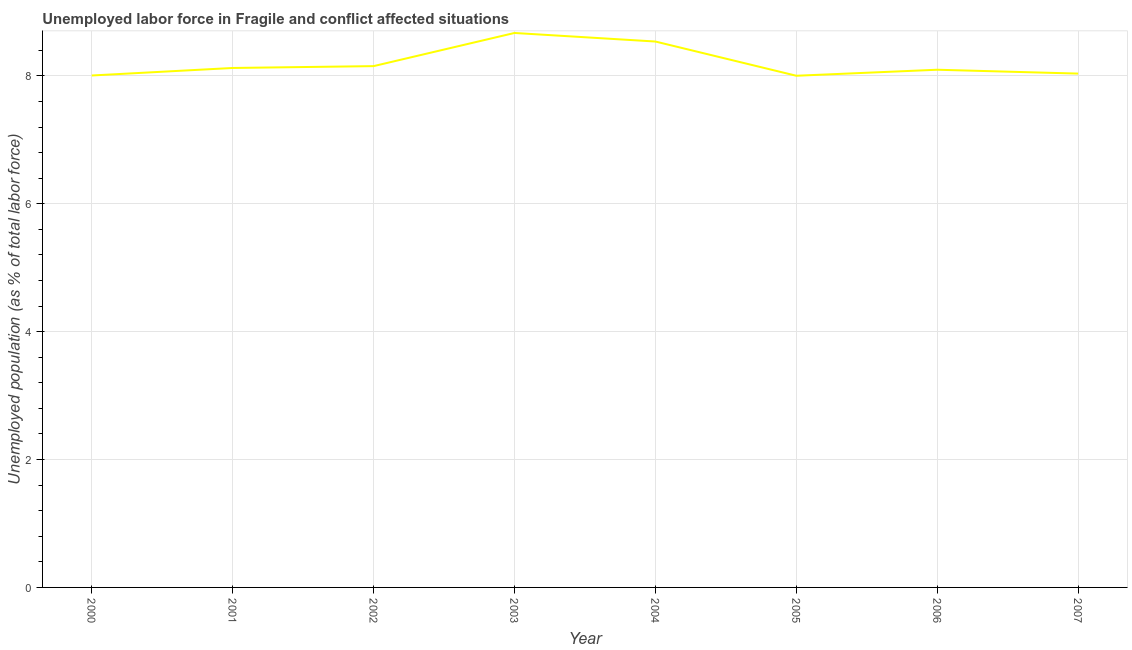What is the total unemployed population in 2005?
Offer a very short reply. 8. Across all years, what is the maximum total unemployed population?
Provide a short and direct response. 8.67. Across all years, what is the minimum total unemployed population?
Your answer should be very brief. 8. In which year was the total unemployed population maximum?
Offer a very short reply. 2003. In which year was the total unemployed population minimum?
Make the answer very short. 2005. What is the sum of the total unemployed population?
Your answer should be very brief. 65.63. What is the difference between the total unemployed population in 2003 and 2006?
Your answer should be compact. 0.58. What is the average total unemployed population per year?
Keep it short and to the point. 8.2. What is the median total unemployed population?
Your answer should be compact. 8.11. In how many years, is the total unemployed population greater than 5.2 %?
Ensure brevity in your answer.  8. What is the ratio of the total unemployed population in 2004 to that in 2007?
Provide a short and direct response. 1.06. Is the total unemployed population in 2000 less than that in 2007?
Your answer should be compact. Yes. What is the difference between the highest and the second highest total unemployed population?
Ensure brevity in your answer.  0.13. What is the difference between the highest and the lowest total unemployed population?
Your answer should be compact. 0.67. In how many years, is the total unemployed population greater than the average total unemployed population taken over all years?
Your response must be concise. 2. How many lines are there?
Ensure brevity in your answer.  1. Does the graph contain any zero values?
Offer a terse response. No. What is the title of the graph?
Your answer should be very brief. Unemployed labor force in Fragile and conflict affected situations. What is the label or title of the Y-axis?
Your response must be concise. Unemployed population (as % of total labor force). What is the Unemployed population (as % of total labor force) in 2000?
Provide a succinct answer. 8.01. What is the Unemployed population (as % of total labor force) in 2001?
Give a very brief answer. 8.12. What is the Unemployed population (as % of total labor force) in 2002?
Your answer should be compact. 8.15. What is the Unemployed population (as % of total labor force) of 2003?
Ensure brevity in your answer.  8.67. What is the Unemployed population (as % of total labor force) of 2004?
Your answer should be very brief. 8.54. What is the Unemployed population (as % of total labor force) in 2005?
Offer a very short reply. 8. What is the Unemployed population (as % of total labor force) in 2006?
Offer a very short reply. 8.1. What is the Unemployed population (as % of total labor force) in 2007?
Offer a very short reply. 8.04. What is the difference between the Unemployed population (as % of total labor force) in 2000 and 2001?
Make the answer very short. -0.12. What is the difference between the Unemployed population (as % of total labor force) in 2000 and 2002?
Provide a succinct answer. -0.15. What is the difference between the Unemployed population (as % of total labor force) in 2000 and 2003?
Keep it short and to the point. -0.67. What is the difference between the Unemployed population (as % of total labor force) in 2000 and 2004?
Keep it short and to the point. -0.53. What is the difference between the Unemployed population (as % of total labor force) in 2000 and 2005?
Ensure brevity in your answer.  0. What is the difference between the Unemployed population (as % of total labor force) in 2000 and 2006?
Your response must be concise. -0.09. What is the difference between the Unemployed population (as % of total labor force) in 2000 and 2007?
Your answer should be compact. -0.03. What is the difference between the Unemployed population (as % of total labor force) in 2001 and 2002?
Offer a terse response. -0.03. What is the difference between the Unemployed population (as % of total labor force) in 2001 and 2003?
Ensure brevity in your answer.  -0.55. What is the difference between the Unemployed population (as % of total labor force) in 2001 and 2004?
Your answer should be compact. -0.41. What is the difference between the Unemployed population (as % of total labor force) in 2001 and 2005?
Your response must be concise. 0.12. What is the difference between the Unemployed population (as % of total labor force) in 2001 and 2006?
Your answer should be very brief. 0.03. What is the difference between the Unemployed population (as % of total labor force) in 2001 and 2007?
Your answer should be compact. 0.09. What is the difference between the Unemployed population (as % of total labor force) in 2002 and 2003?
Make the answer very short. -0.52. What is the difference between the Unemployed population (as % of total labor force) in 2002 and 2004?
Offer a terse response. -0.38. What is the difference between the Unemployed population (as % of total labor force) in 2002 and 2005?
Ensure brevity in your answer.  0.15. What is the difference between the Unemployed population (as % of total labor force) in 2002 and 2006?
Provide a short and direct response. 0.06. What is the difference between the Unemployed population (as % of total labor force) in 2002 and 2007?
Your answer should be compact. 0.12. What is the difference between the Unemployed population (as % of total labor force) in 2003 and 2004?
Your answer should be compact. 0.13. What is the difference between the Unemployed population (as % of total labor force) in 2003 and 2005?
Your answer should be compact. 0.67. What is the difference between the Unemployed population (as % of total labor force) in 2003 and 2006?
Offer a very short reply. 0.58. What is the difference between the Unemployed population (as % of total labor force) in 2003 and 2007?
Ensure brevity in your answer.  0.64. What is the difference between the Unemployed population (as % of total labor force) in 2004 and 2005?
Offer a terse response. 0.54. What is the difference between the Unemployed population (as % of total labor force) in 2004 and 2006?
Make the answer very short. 0.44. What is the difference between the Unemployed population (as % of total labor force) in 2004 and 2007?
Offer a terse response. 0.5. What is the difference between the Unemployed population (as % of total labor force) in 2005 and 2006?
Offer a terse response. -0.09. What is the difference between the Unemployed population (as % of total labor force) in 2005 and 2007?
Offer a terse response. -0.03. What is the difference between the Unemployed population (as % of total labor force) in 2006 and 2007?
Give a very brief answer. 0.06. What is the ratio of the Unemployed population (as % of total labor force) in 2000 to that in 2002?
Keep it short and to the point. 0.98. What is the ratio of the Unemployed population (as % of total labor force) in 2000 to that in 2003?
Offer a terse response. 0.92. What is the ratio of the Unemployed population (as % of total labor force) in 2000 to that in 2004?
Provide a short and direct response. 0.94. What is the ratio of the Unemployed population (as % of total labor force) in 2000 to that in 2005?
Offer a very short reply. 1. What is the ratio of the Unemployed population (as % of total labor force) in 2000 to that in 2006?
Offer a very short reply. 0.99. What is the ratio of the Unemployed population (as % of total labor force) in 2000 to that in 2007?
Ensure brevity in your answer.  1. What is the ratio of the Unemployed population (as % of total labor force) in 2001 to that in 2002?
Offer a terse response. 1. What is the ratio of the Unemployed population (as % of total labor force) in 2001 to that in 2003?
Provide a short and direct response. 0.94. What is the ratio of the Unemployed population (as % of total labor force) in 2001 to that in 2005?
Ensure brevity in your answer.  1.01. What is the ratio of the Unemployed population (as % of total labor force) in 2001 to that in 2006?
Give a very brief answer. 1. What is the ratio of the Unemployed population (as % of total labor force) in 2002 to that in 2003?
Offer a terse response. 0.94. What is the ratio of the Unemployed population (as % of total labor force) in 2002 to that in 2004?
Make the answer very short. 0.95. What is the ratio of the Unemployed population (as % of total labor force) in 2002 to that in 2005?
Provide a succinct answer. 1.02. What is the ratio of the Unemployed population (as % of total labor force) in 2003 to that in 2004?
Offer a very short reply. 1.02. What is the ratio of the Unemployed population (as % of total labor force) in 2003 to that in 2005?
Offer a very short reply. 1.08. What is the ratio of the Unemployed population (as % of total labor force) in 2003 to that in 2006?
Give a very brief answer. 1.07. What is the ratio of the Unemployed population (as % of total labor force) in 2003 to that in 2007?
Your answer should be very brief. 1.08. What is the ratio of the Unemployed population (as % of total labor force) in 2004 to that in 2005?
Provide a succinct answer. 1.07. What is the ratio of the Unemployed population (as % of total labor force) in 2004 to that in 2006?
Offer a terse response. 1.05. What is the ratio of the Unemployed population (as % of total labor force) in 2004 to that in 2007?
Provide a short and direct response. 1.06. 